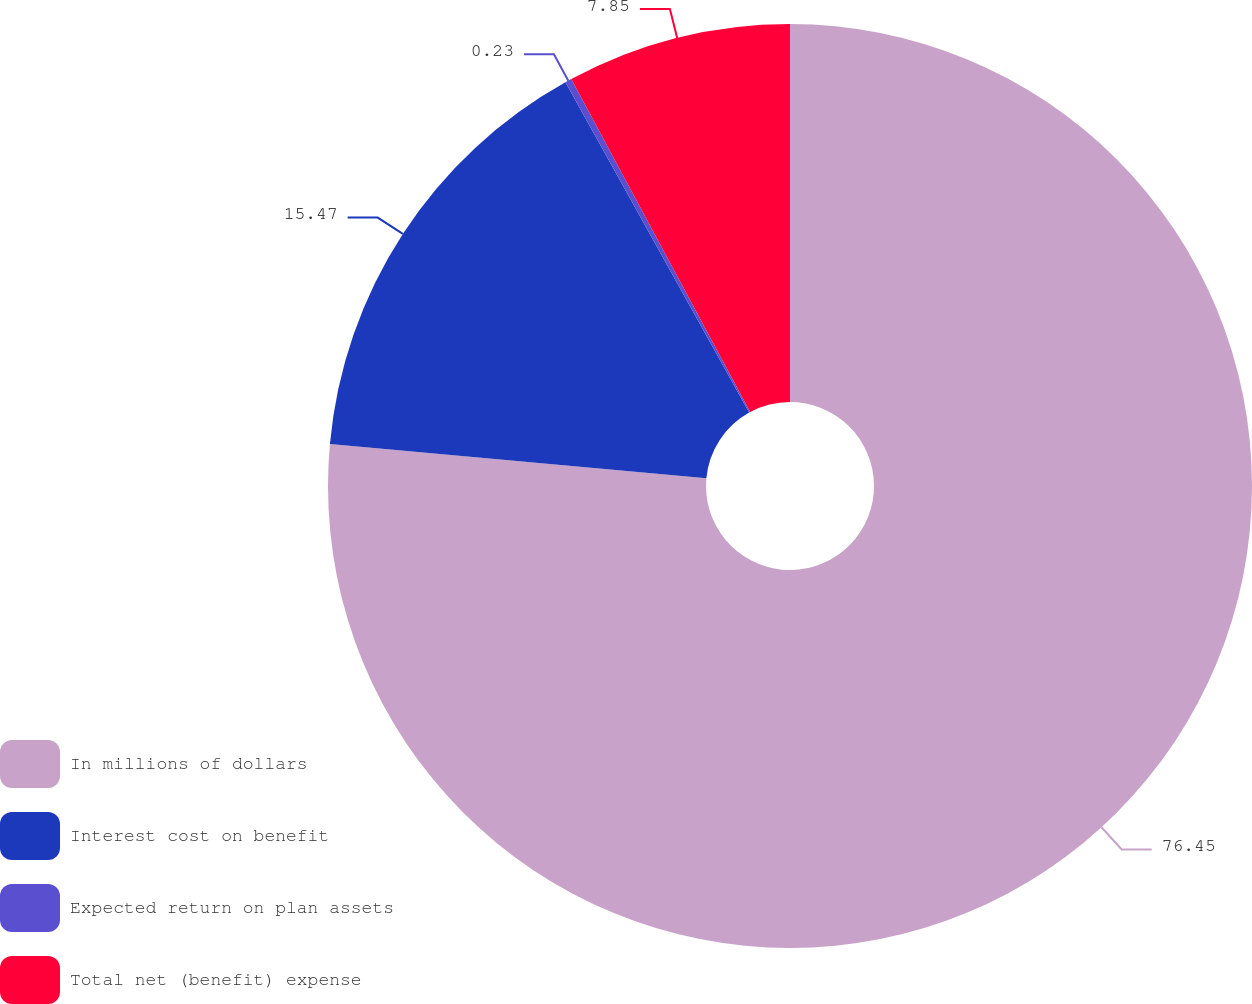Convert chart. <chart><loc_0><loc_0><loc_500><loc_500><pie_chart><fcel>In millions of dollars<fcel>Interest cost on benefit<fcel>Expected return on plan assets<fcel>Total net (benefit) expense<nl><fcel>76.45%<fcel>15.47%<fcel>0.23%<fcel>7.85%<nl></chart> 